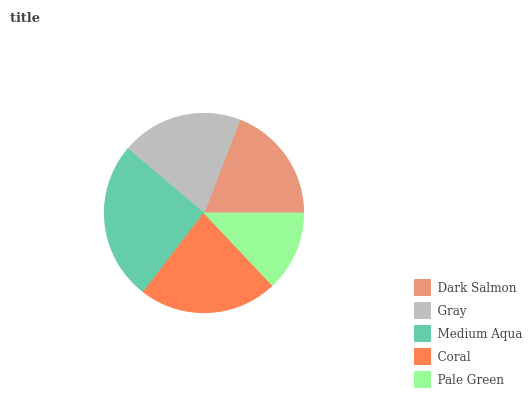Is Pale Green the minimum?
Answer yes or no. Yes. Is Medium Aqua the maximum?
Answer yes or no. Yes. Is Gray the minimum?
Answer yes or no. No. Is Gray the maximum?
Answer yes or no. No. Is Gray greater than Dark Salmon?
Answer yes or no. Yes. Is Dark Salmon less than Gray?
Answer yes or no. Yes. Is Dark Salmon greater than Gray?
Answer yes or no. No. Is Gray less than Dark Salmon?
Answer yes or no. No. Is Gray the high median?
Answer yes or no. Yes. Is Gray the low median?
Answer yes or no. Yes. Is Medium Aqua the high median?
Answer yes or no. No. Is Coral the low median?
Answer yes or no. No. 